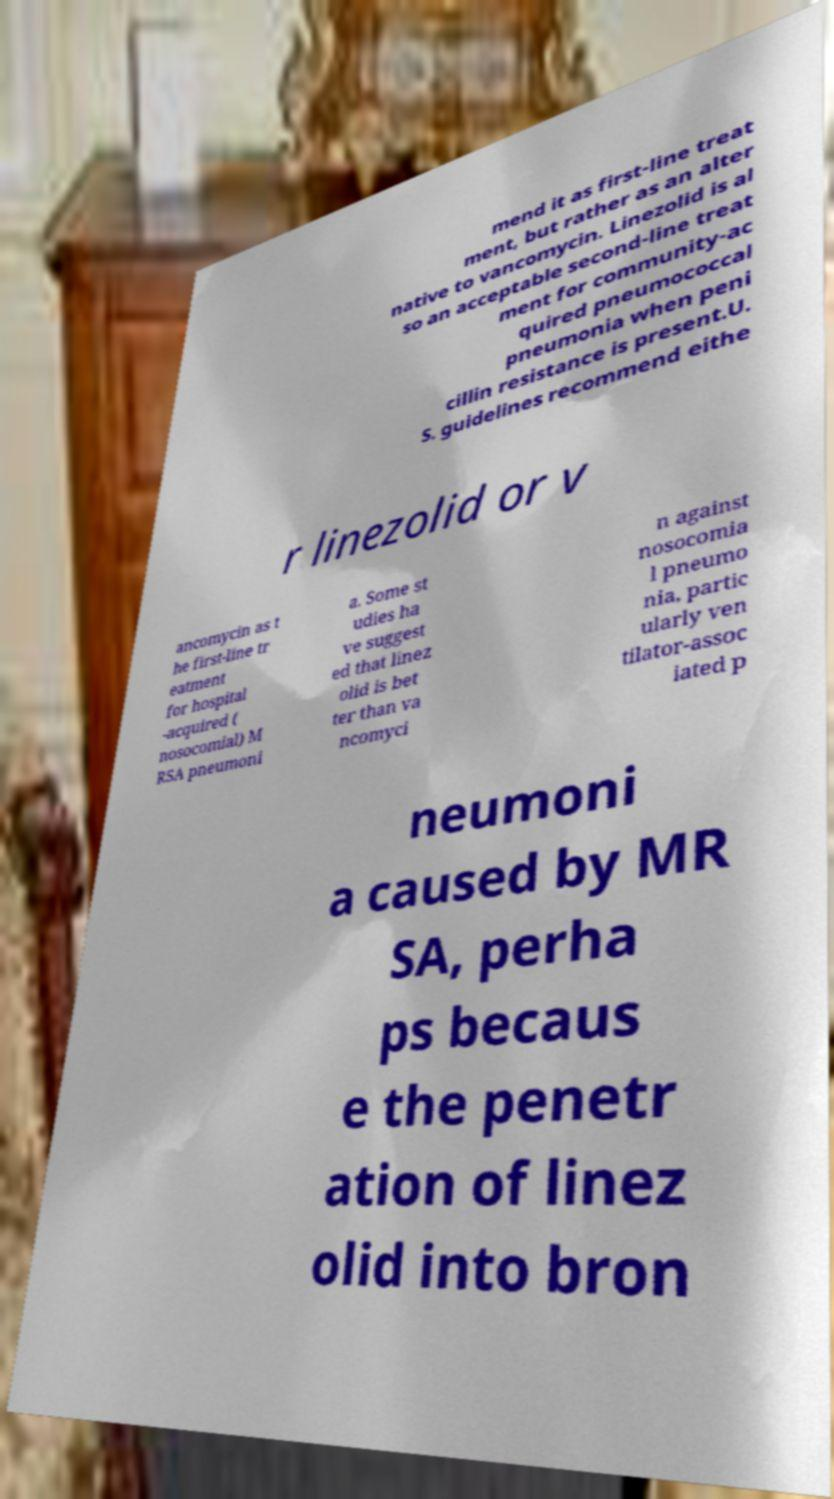For documentation purposes, I need the text within this image transcribed. Could you provide that? mend it as first-line treat ment, but rather as an alter native to vancomycin. Linezolid is al so an acceptable second-line treat ment for community-ac quired pneumococcal pneumonia when peni cillin resistance is present.U. S. guidelines recommend eithe r linezolid or v ancomycin as t he first-line tr eatment for hospital -acquired ( nosocomial) M RSA pneumoni a. Some st udies ha ve suggest ed that linez olid is bet ter than va ncomyci n against nosocomia l pneumo nia, partic ularly ven tilator-assoc iated p neumoni a caused by MR SA, perha ps becaus e the penetr ation of linez olid into bron 